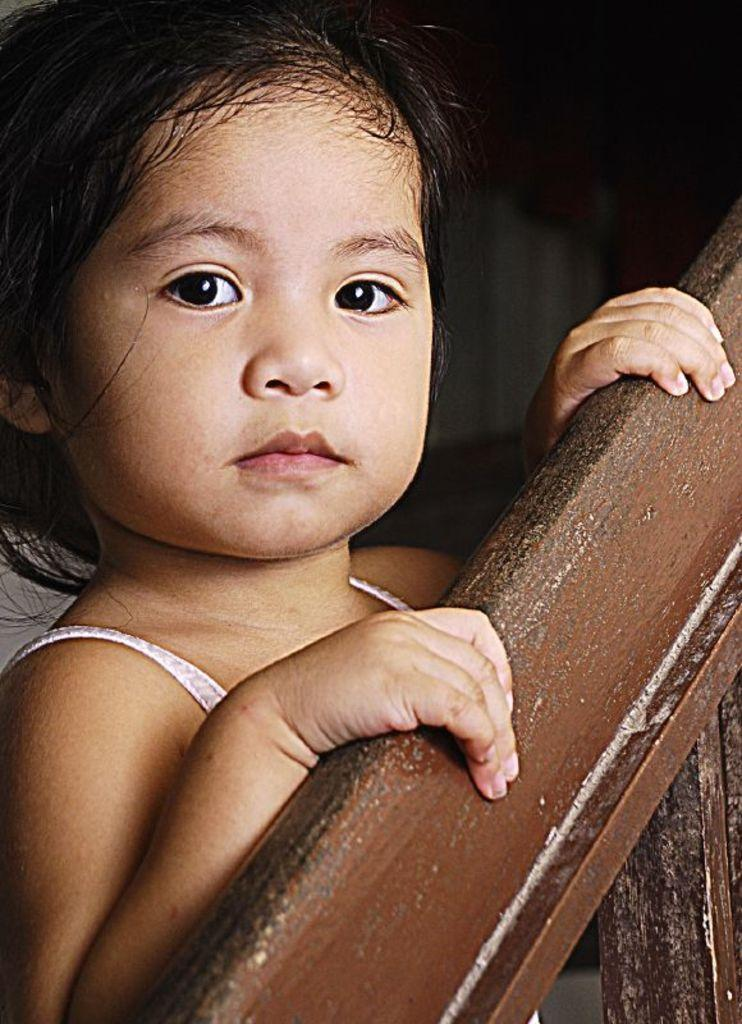What is the main subject in the image? There is a girl standing in the image. What can be seen on the right side of the image? There is a railing on the right side of the image. How many minutes does it take for the girl to print her document in the image? There is no mention of printing or documents in the image, so it is not possible to answer this question. 